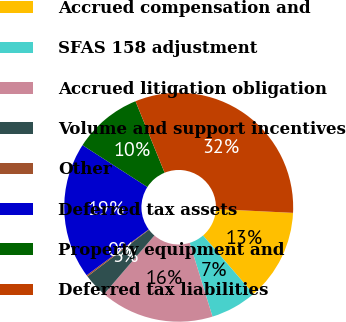Convert chart to OTSL. <chart><loc_0><loc_0><loc_500><loc_500><pie_chart><fcel>Accrued compensation and<fcel>SFAS 158 adjustment<fcel>Accrued litigation obligation<fcel>Volume and support incentives<fcel>Other<fcel>Deferred tax assets<fcel>Property equipment and<fcel>Deferred tax liabilities<nl><fcel>12.9%<fcel>6.55%<fcel>16.07%<fcel>3.37%<fcel>0.2%<fcel>19.25%<fcel>9.72%<fcel>31.94%<nl></chart> 